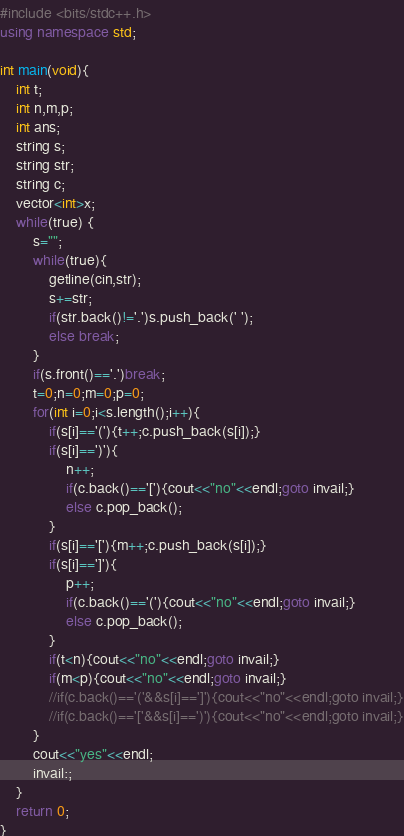<code> <loc_0><loc_0><loc_500><loc_500><_C++_>#include <bits/stdc++.h>
using namespace std;

int main(void){
    int t;
    int n,m,p;
    int ans;
    string s;
    string str;
    string c;
    vector<int>x;
    while(true) {
        s="";
        while(true){
            getline(cin,str);
            s+=str;
            if(str.back()!='.')s.push_back(' ');
            else break;
        }
        if(s.front()=='.')break;
        t=0;n=0;m=0;p=0;
        for(int i=0;i<s.length();i++){
            if(s[i]=='('){t++;c.push_back(s[i]);}
            if(s[i]==')'){
                n++;
                if(c.back()=='['){cout<<"no"<<endl;goto invail;}
                else c.pop_back();
            }
            if(s[i]=='['){m++;c.push_back(s[i]);}
            if(s[i]==']'){
                p++;
                if(c.back()=='('){cout<<"no"<<endl;goto invail;}
                else c.pop_back();
            }
            if(t<n){cout<<"no"<<endl;goto invail;}
            if(m<p){cout<<"no"<<endl;goto invail;}
            //if(c.back()=='('&&s[i]==']'){cout<<"no"<<endl;goto invail;}
            //if(c.back()=='['&&s[i]==')'){cout<<"no"<<endl;goto invail;}
        }
        cout<<"yes"<<endl;
        invail:;
    }
    return 0;
}
</code> 